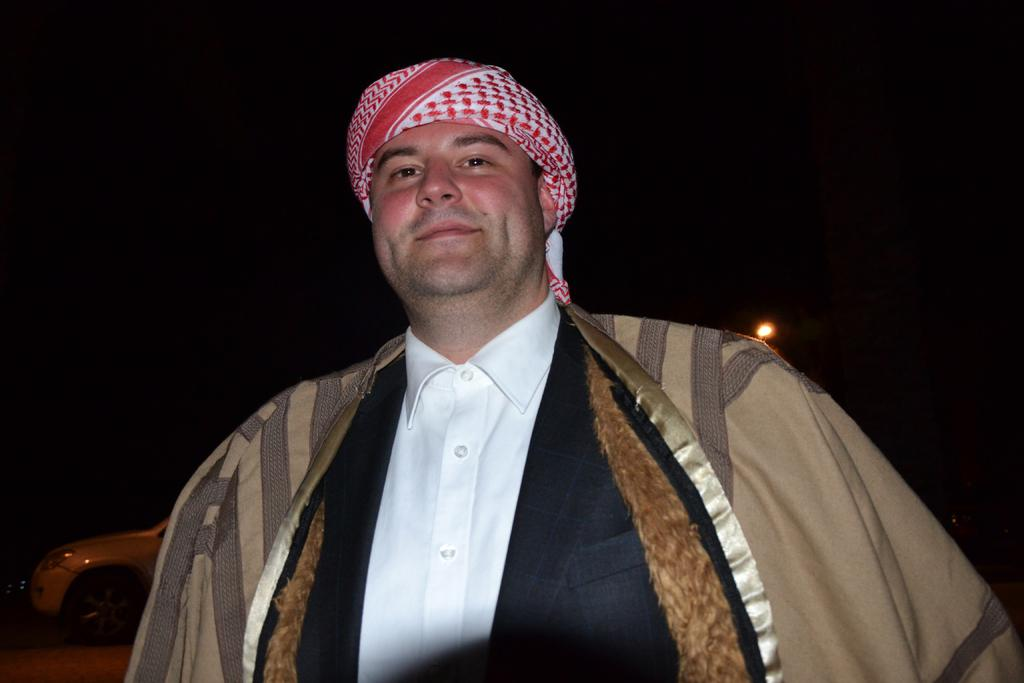What is the main subject of the image? There is a person in the image. What is the person wearing on their head? The person is wearing a red object on their head. What can be seen behind the person? There is a car behind the person. What type of writing can be seen on the red object the person is wearing? There is no writing visible on the red object in the image. 